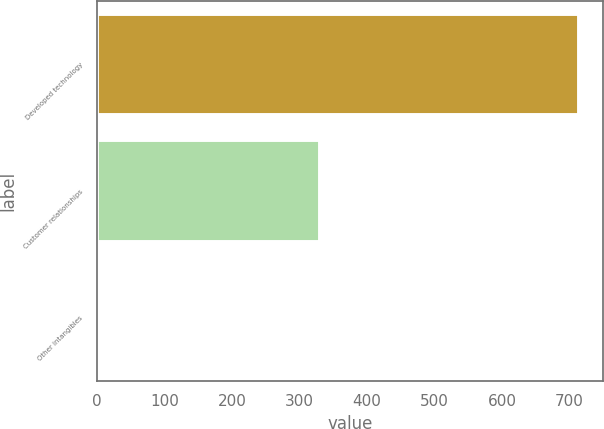<chart> <loc_0><loc_0><loc_500><loc_500><bar_chart><fcel>Developed technology<fcel>Customer relationships<fcel>Other intangibles<nl><fcel>714<fcel>330<fcel>2<nl></chart> 